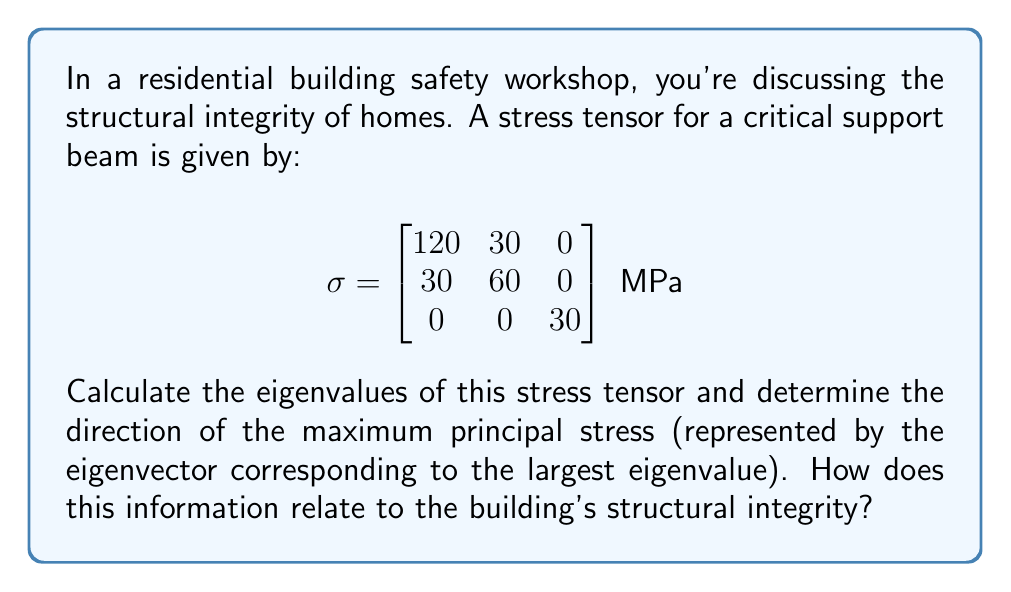Provide a solution to this math problem. 1) To find the eigenvalues, we solve the characteristic equation:
   $$\det(\sigma - \lambda I) = 0$$

2) Expanding the determinant:
   $$\begin{vmatrix}
   120-\lambda & 30 & 0 \\
   30 & 60-\lambda & 0 \\
   0 & 0 & 30-\lambda
   \end{vmatrix} = 0$$

3) This gives:
   $$(120-\lambda)(60-\lambda)(30-\lambda) - 900(30-\lambda) = 0$$

4) Simplifying:
   $$\lambda^3 - 210\lambda^2 + 13500\lambda - 270000 = 0$$

5) Solving this cubic equation (using a calculator or computer algebra system) yields:
   $$\lambda_1 \approx 132.8 \text{ MPa}, \lambda_2 \approx 60 \text{ MPa}, \lambda_3 \approx 17.2 \text{ MPa}$$

6) The largest eigenvalue is $\lambda_1 \approx 132.8 \text{ MPa}$, representing the maximum principal stress.

7) To find the corresponding eigenvector, we solve:
   $$(\sigma - \lambda_1 I)\vec{v} = \vec{0}$$

8) This gives:
   $$\begin{bmatrix}
   -12.8 & 30 & 0 \\
   30 & -72.8 & 0 \\
   0 & 0 & -102.8
   \end{bmatrix}\begin{bmatrix}
   v_1 \\ v_2 \\ v_3
   \end{bmatrix} = \begin{bmatrix}
   0 \\ 0 \\ 0
   \end{bmatrix}$$

9) Solving this system (and normalizing) yields the eigenvector:
   $$\vec{v} \approx (0.905, 0.426, 0)$$

10) This eigenvector represents the direction of maximum principal stress, which is approximately 25.2° from the x-axis in the xy-plane.

11) For structural integrity: The maximum stress (132.8 MPa) should be compared to the material's yield strength. The direction (25.2° from x-axis) indicates where reinforcement might be needed.
Answer: Eigenvalues: 132.8 MPa, 60 MPa, 17.2 MPa. Maximum stress direction: (0.905, 0.426, 0), 25.2° from x-axis in xy-plane. 